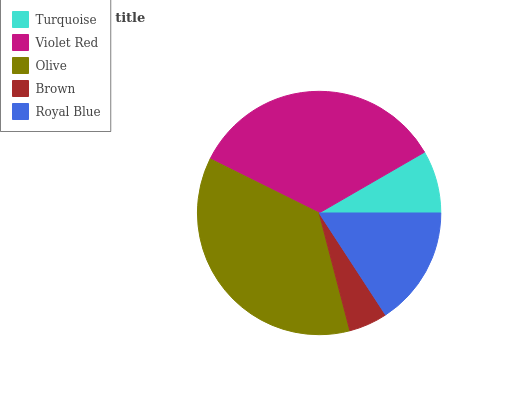Is Brown the minimum?
Answer yes or no. Yes. Is Olive the maximum?
Answer yes or no. Yes. Is Violet Red the minimum?
Answer yes or no. No. Is Violet Red the maximum?
Answer yes or no. No. Is Violet Red greater than Turquoise?
Answer yes or no. Yes. Is Turquoise less than Violet Red?
Answer yes or no. Yes. Is Turquoise greater than Violet Red?
Answer yes or no. No. Is Violet Red less than Turquoise?
Answer yes or no. No. Is Royal Blue the high median?
Answer yes or no. Yes. Is Royal Blue the low median?
Answer yes or no. Yes. Is Turquoise the high median?
Answer yes or no. No. Is Olive the low median?
Answer yes or no. No. 